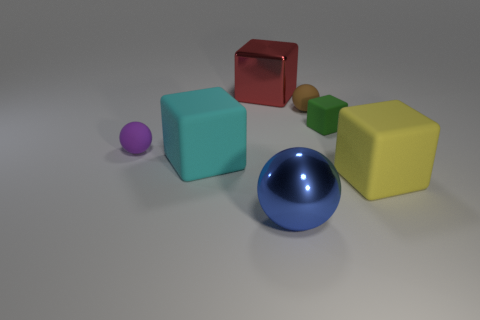Add 2 red shiny cubes. How many objects exist? 9 Subtract all blocks. How many objects are left? 3 Add 5 large brown rubber cylinders. How many large brown rubber cylinders exist? 5 Subtract 0 cyan spheres. How many objects are left? 7 Subtract all brown rubber spheres. Subtract all big shiny things. How many objects are left? 4 Add 6 small green cubes. How many small green cubes are left? 7 